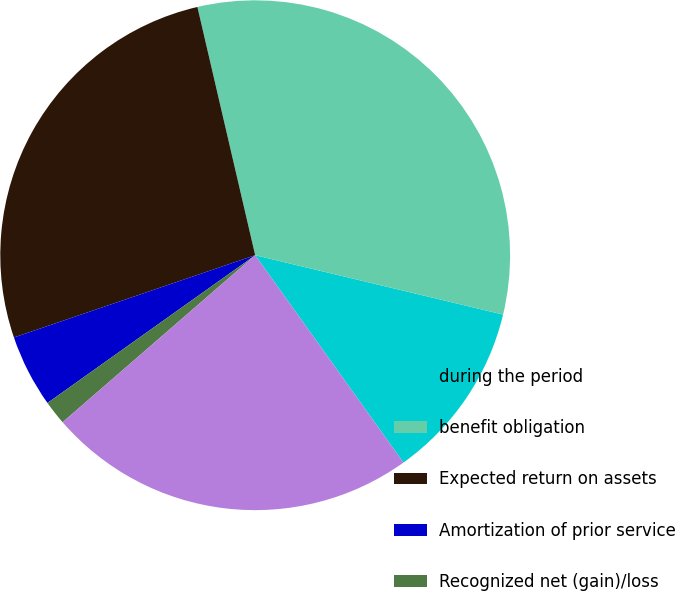Convert chart to OTSL. <chart><loc_0><loc_0><loc_500><loc_500><pie_chart><fcel>during the period<fcel>benefit obligation<fcel>Expected return on assets<fcel>Amortization of prior service<fcel>Recognized net (gain)/loss<fcel>Net pension cost (income)<nl><fcel>11.38%<fcel>32.38%<fcel>26.59%<fcel>4.61%<fcel>1.53%<fcel>23.51%<nl></chart> 